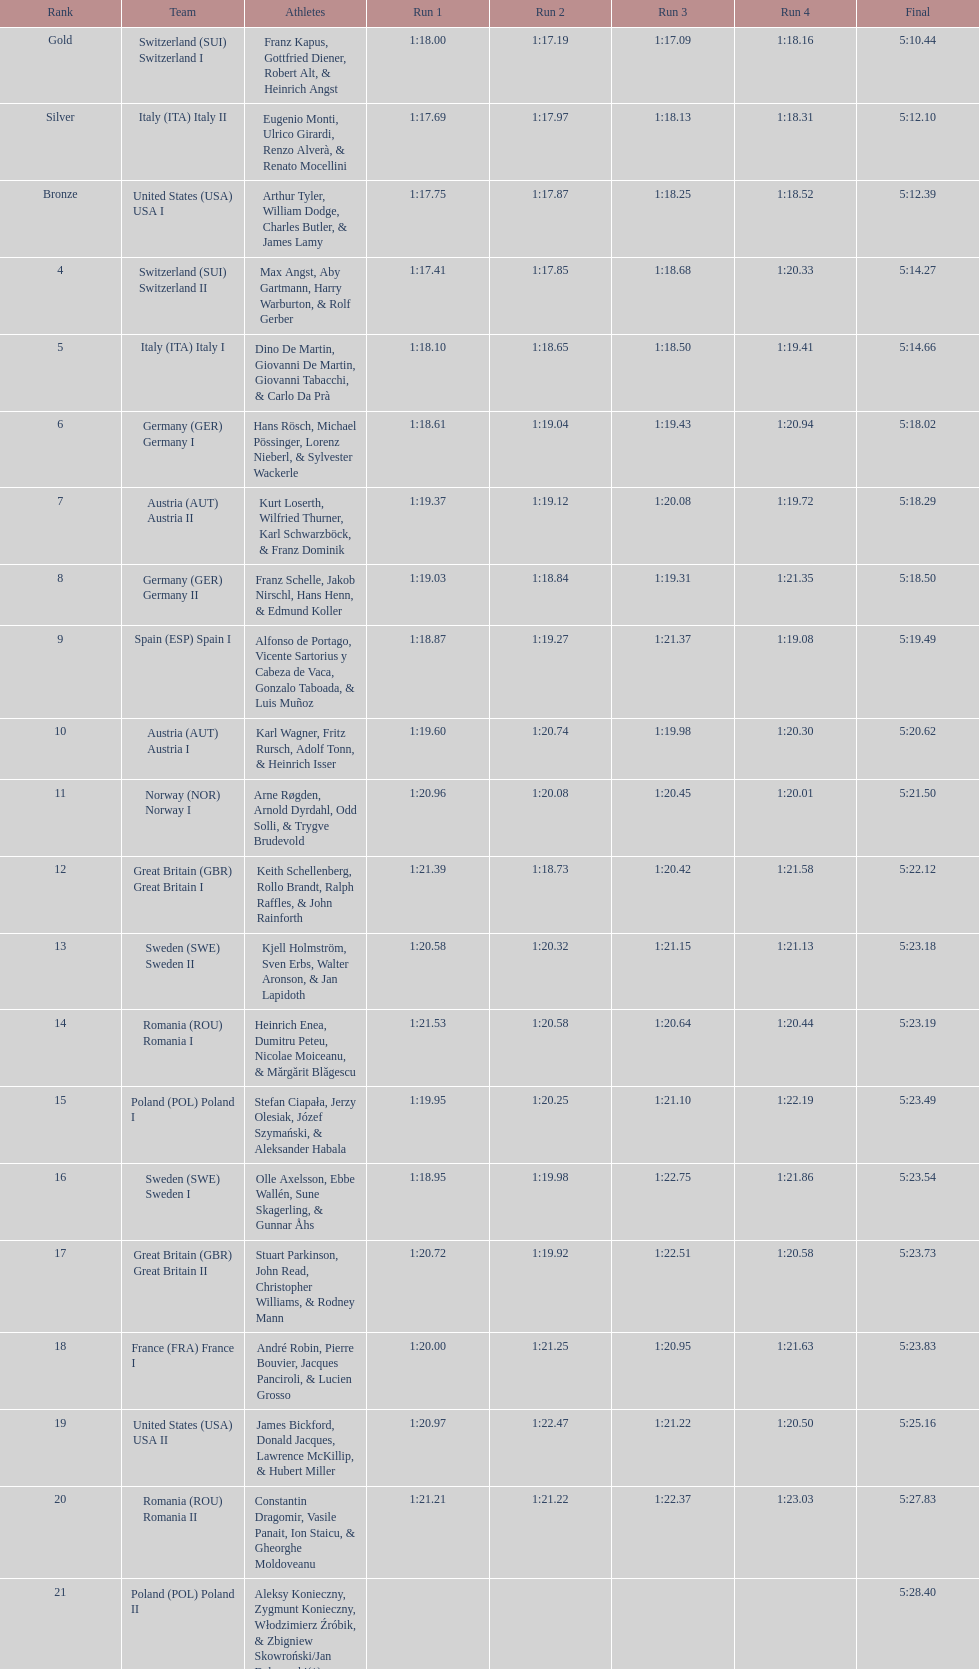Which team possessed the most time? Poland. Give me the full table as a dictionary. {'header': ['Rank', 'Team', 'Athletes', 'Run 1', 'Run 2', 'Run 3', 'Run 4', 'Final'], 'rows': [['Gold', 'Switzerland\xa0(SUI) Switzerland I', 'Franz Kapus, Gottfried Diener, Robert Alt, & Heinrich Angst', '1:18.00', '1:17.19', '1:17.09', '1:18.16', '5:10.44'], ['Silver', 'Italy\xa0(ITA) Italy II', 'Eugenio Monti, Ulrico Girardi, Renzo Alverà, & Renato Mocellini', '1:17.69', '1:17.97', '1:18.13', '1:18.31', '5:12.10'], ['Bronze', 'United States\xa0(USA) USA I', 'Arthur Tyler, William Dodge, Charles Butler, & James Lamy', '1:17.75', '1:17.87', '1:18.25', '1:18.52', '5:12.39'], ['4', 'Switzerland\xa0(SUI) Switzerland II', 'Max Angst, Aby Gartmann, Harry Warburton, & Rolf Gerber', '1:17.41', '1:17.85', '1:18.68', '1:20.33', '5:14.27'], ['5', 'Italy\xa0(ITA) Italy I', 'Dino De Martin, Giovanni De Martin, Giovanni Tabacchi, & Carlo Da Prà', '1:18.10', '1:18.65', '1:18.50', '1:19.41', '5:14.66'], ['6', 'Germany\xa0(GER) Germany I', 'Hans Rösch, Michael Pössinger, Lorenz Nieberl, & Sylvester Wackerle', '1:18.61', '1:19.04', '1:19.43', '1:20.94', '5:18.02'], ['7', 'Austria\xa0(AUT) Austria II', 'Kurt Loserth, Wilfried Thurner, Karl Schwarzböck, & Franz Dominik', '1:19.37', '1:19.12', '1:20.08', '1:19.72', '5:18.29'], ['8', 'Germany\xa0(GER) Germany II', 'Franz Schelle, Jakob Nirschl, Hans Henn, & Edmund Koller', '1:19.03', '1:18.84', '1:19.31', '1:21.35', '5:18.50'], ['9', 'Spain\xa0(ESP) Spain I', 'Alfonso de Portago, Vicente Sartorius y Cabeza de Vaca, Gonzalo Taboada, & Luis Muñoz', '1:18.87', '1:19.27', '1:21.37', '1:19.08', '5:19.49'], ['10', 'Austria\xa0(AUT) Austria I', 'Karl Wagner, Fritz Rursch, Adolf Tonn, & Heinrich Isser', '1:19.60', '1:20.74', '1:19.98', '1:20.30', '5:20.62'], ['11', 'Norway\xa0(NOR) Norway I', 'Arne Røgden, Arnold Dyrdahl, Odd Solli, & Trygve Brudevold', '1:20.96', '1:20.08', '1:20.45', '1:20.01', '5:21.50'], ['12', 'Great Britain\xa0(GBR) Great Britain I', 'Keith Schellenberg, Rollo Brandt, Ralph Raffles, & John Rainforth', '1:21.39', '1:18.73', '1:20.42', '1:21.58', '5:22.12'], ['13', 'Sweden\xa0(SWE) Sweden II', 'Kjell Holmström, Sven Erbs, Walter Aronson, & Jan Lapidoth', '1:20.58', '1:20.32', '1:21.15', '1:21.13', '5:23.18'], ['14', 'Romania\xa0(ROU) Romania I', 'Heinrich Enea, Dumitru Peteu, Nicolae Moiceanu, & Mărgărit Blăgescu', '1:21.53', '1:20.58', '1:20.64', '1:20.44', '5:23.19'], ['15', 'Poland\xa0(POL) Poland I', 'Stefan Ciapała, Jerzy Olesiak, Józef Szymański, & Aleksander Habala', '1:19.95', '1:20.25', '1:21.10', '1:22.19', '5:23.49'], ['16', 'Sweden\xa0(SWE) Sweden I', 'Olle Axelsson, Ebbe Wallén, Sune Skagerling, & Gunnar Åhs', '1:18.95', '1:19.98', '1:22.75', '1:21.86', '5:23.54'], ['17', 'Great Britain\xa0(GBR) Great Britain II', 'Stuart Parkinson, John Read, Christopher Williams, & Rodney Mann', '1:20.72', '1:19.92', '1:22.51', '1:20.58', '5:23.73'], ['18', 'France\xa0(FRA) France I', 'André Robin, Pierre Bouvier, Jacques Panciroli, & Lucien Grosso', '1:20.00', '1:21.25', '1:20.95', '1:21.63', '5:23.83'], ['19', 'United States\xa0(USA) USA II', 'James Bickford, Donald Jacques, Lawrence McKillip, & Hubert Miller', '1:20.97', '1:22.47', '1:21.22', '1:20.50', '5:25.16'], ['20', 'Romania\xa0(ROU) Romania II', 'Constantin Dragomir, Vasile Panait, Ion Staicu, & Gheorghe Moldoveanu', '1:21.21', '1:21.22', '1:22.37', '1:23.03', '5:27.83'], ['21', 'Poland\xa0(POL) Poland II', 'Aleksy Konieczny, Zygmunt Konieczny, Włodzimierz Źróbik, & Zbigniew Skowroński/Jan Dąbrowski(*)', '', '', '', '', '5:28.40']]} 